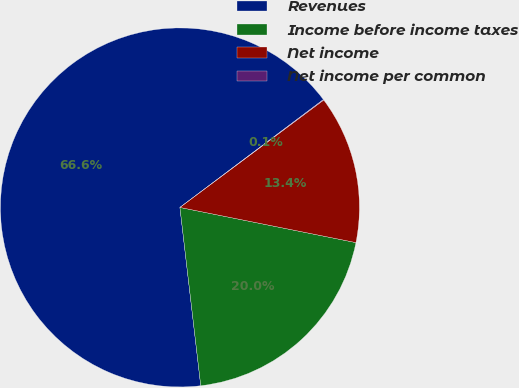Convert chart to OTSL. <chart><loc_0><loc_0><loc_500><loc_500><pie_chart><fcel>Revenues<fcel>Income before income taxes<fcel>Net income<fcel>Net income per common<nl><fcel>66.59%<fcel>20.01%<fcel>13.35%<fcel>0.05%<nl></chart> 